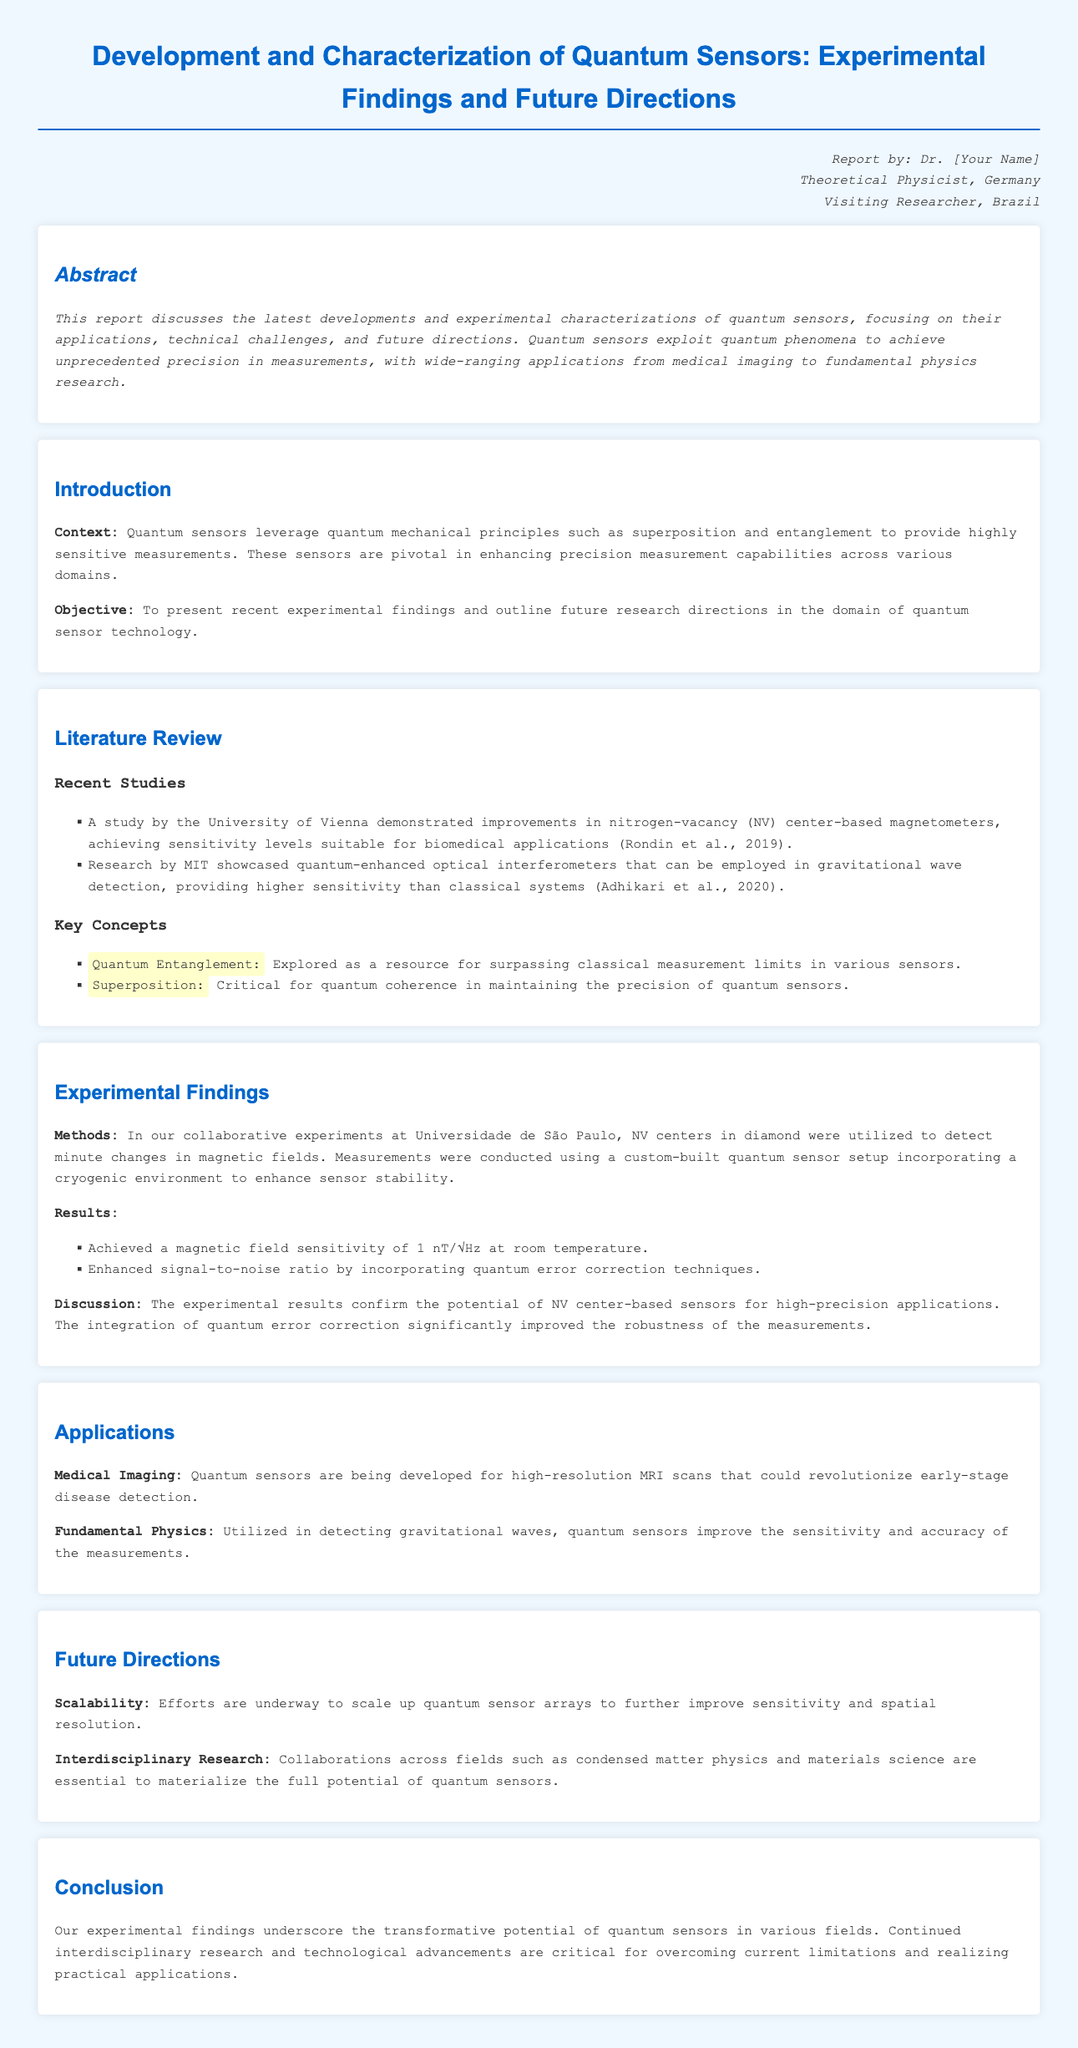What is the primary objective of this lab report? The objective is to present recent experimental findings and outline future research directions in the domain of quantum sensor technology.
Answer: To present recent experimental findings and outline future research directions in the domain of quantum sensor technology What sensitivity level was achieved by the NV center-based sensors at room temperature? The report states that a magnetic field sensitivity of 1 nT/√Hz was achieved.
Answer: 1 nT/√Hz Which university conducted research on nitrogen-vacancy (NV) center-based magnetometers? The University of Vienna is mentioned as conducting a study on NV center-based magnetometers.
Answer: University of Vienna What technique was incorporated to enhance the signal-to-noise ratio? The report mentions that quantum error correction techniques were incorporated to enhance the signal-to-noise ratio.
Answer: Quantum error correction techniques What potential application of quantum sensors is highlighted for medical imaging? The lab report discusses high-resolution MRI scans for early-stage disease detection as a potential application.
Answer: High-resolution MRI scans What is one future direction mentioned for quantum sensors? The report mentions efforts to scale up quantum sensor arrays to improve sensitivity and spatial resolution.
Answer: Scalability 